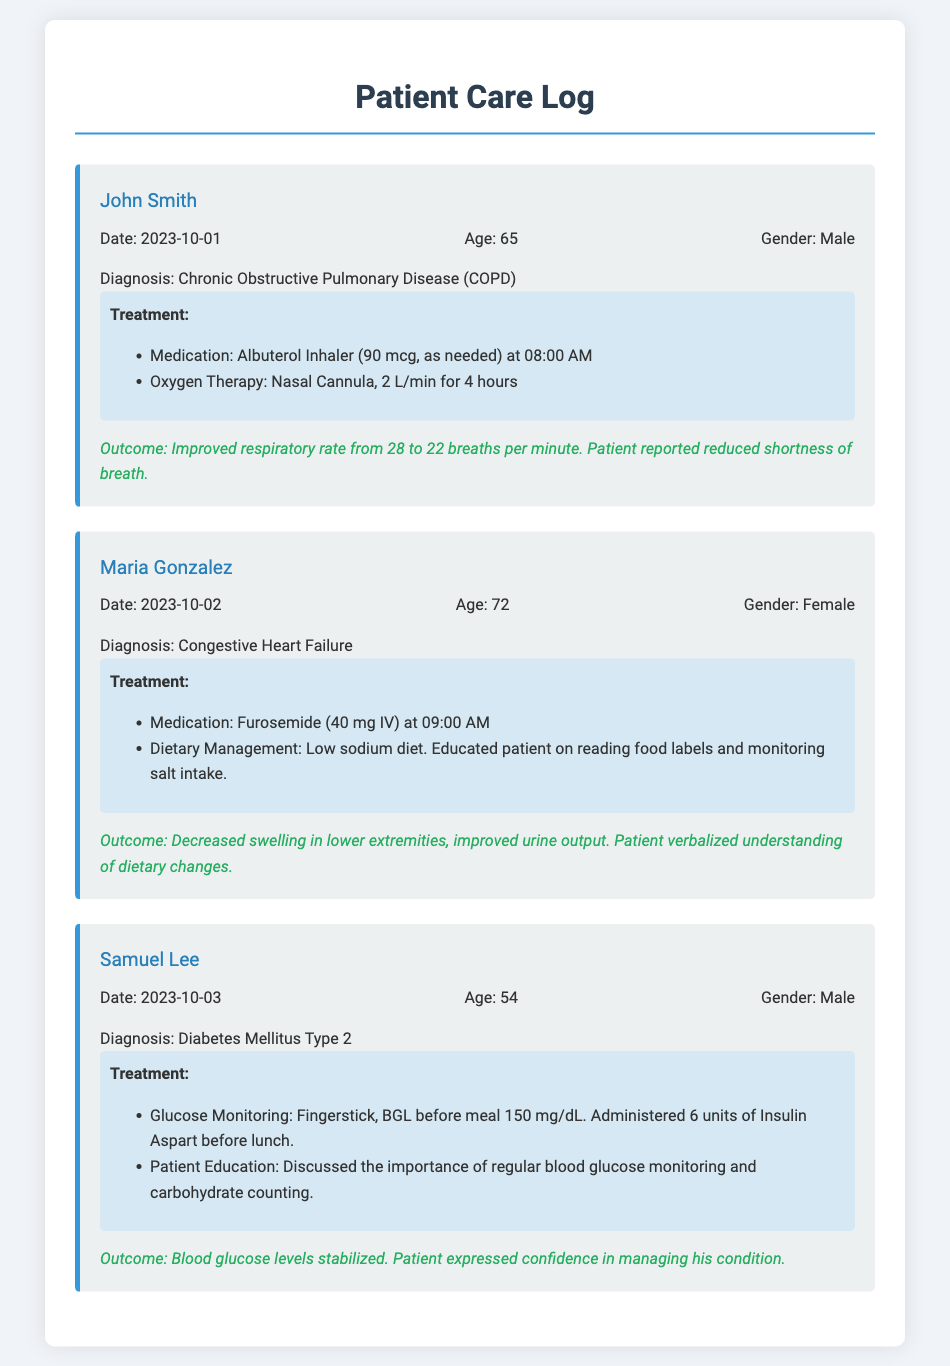what is the name of the first patient? The first patient listed in the document is John Smith.
Answer: John Smith what was the treatment provided to Maria Gonzalez? The treatment for Maria Gonzalez included Furosemide and dietary management.
Answer: Furosemide and dietary management on what date did Samuel Lee receive treatment? Samuel Lee received treatment on October 3, 2023.
Answer: October 3, 2023 how did John Smith's respiratory rate change after treatment? John Smith's respiratory rate improved from 28 to 22 breaths per minute after treatment.
Answer: improved from 28 to 22 breaths per minute what medication was given at 09:00 AM for Maria Gonzalez? Furosemide was administered to Maria Gonzalez at 09:00 AM.
Answer: Furosemide what is the diagnosis for Samuel Lee? Samuel Lee's diagnosis is Diabetes Mellitus Type 2.
Answer: Diabetes Mellitus Type 2 how many liters per minute of oxygen therapy was provided to John Smith? John Smith received oxygen therapy at 2 liters per minute.
Answer: 2 L/min what type of diet was suggested for Maria Gonzalez? A low sodium diet was recommended for Maria Gonzalez.
Answer: Low sodium diet what was the outcome for Samuel Lee after treatment? The outcome for Samuel Lee was stabilized blood glucose levels and confidence in managing his condition.
Answer: Stabilized blood glucose levels and confidence in managing his condition 